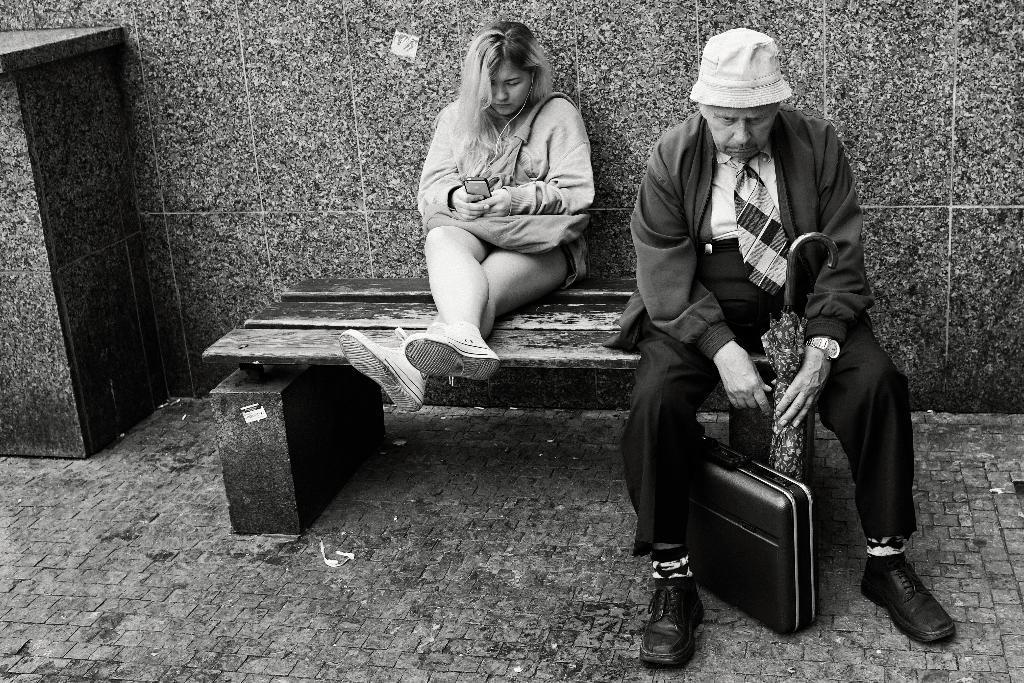Could you give a brief overview of what you see in this image? This is a black and white picture. There are two persons sitting on a bench. The man is holding a umbrella, under the bench there is a suit case. Behind the people there is a wall which is covered with tiles. 